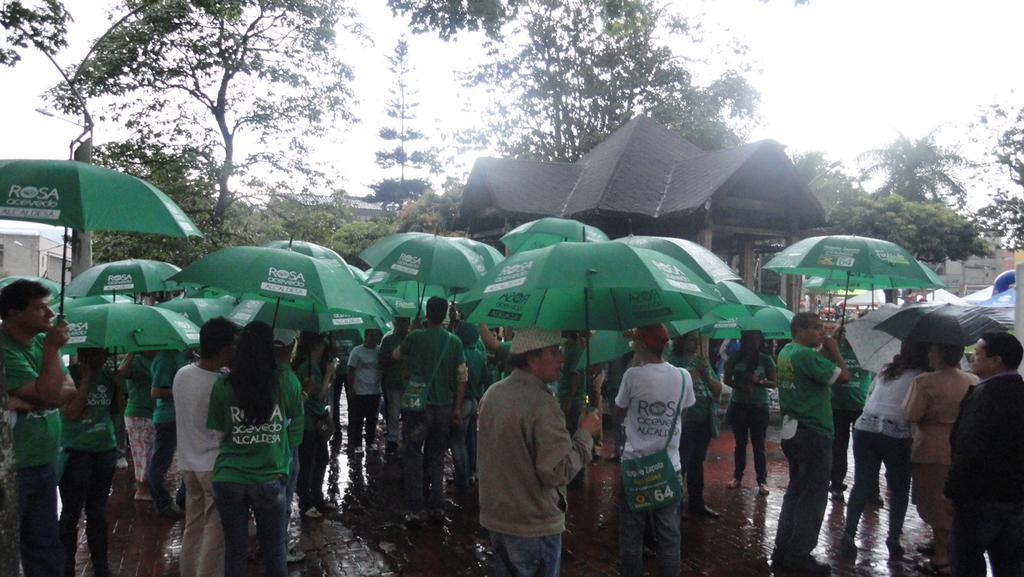What are the people in the image using to protect themselves from the weather? The people in the image are holding umbrellas. Where are the people standing in the image? The people are standing on a path. What can be seen in the background of the image? There are houses and trees in the background of the image. What type of cheese is being carried by the laborer in the image? There is no laborer or cheese present in the image. What is the board used for in the image? There is no board present in the image. 